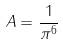<formula> <loc_0><loc_0><loc_500><loc_500>\ A = \frac { 1 } { \pi ^ { 6 } }</formula> 